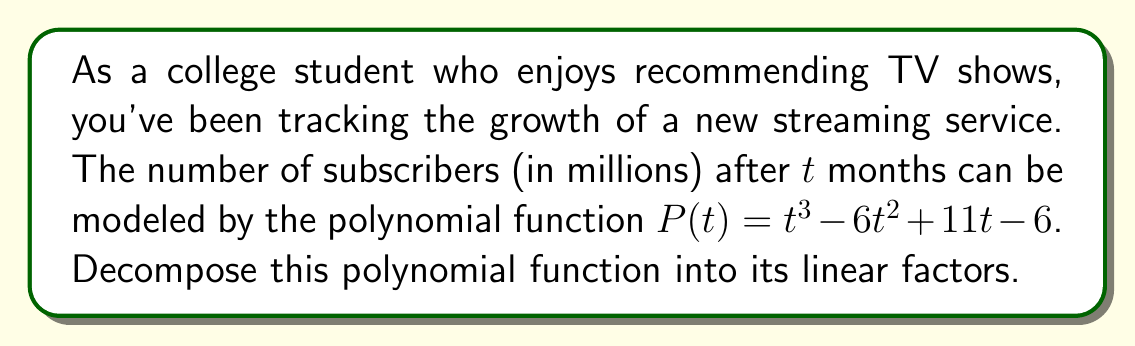Help me with this question. To decompose this polynomial function, we'll follow these steps:

1) First, let's check if there are any rational roots using the rational root theorem. The possible rational roots are the factors of the constant term: $\pm 1, \pm 2, \pm 3, \pm 6$.

2) Testing these values, we find that $P(1) = 0$. So $(t-1)$ is a factor.

3) We can use polynomial long division to divide $P(t)$ by $(t-1)$:

   $$\frac{t^3 - 6t^2 + 11t - 6}{t-1} = t^2 - 5t + 6$$

4) Now we have: $P(t) = (t-1)(t^2 - 5t + 6)$

5) The quadratic factor $t^2 - 5t + 6$ can be factored further:
   
   $$t^2 - 5t + 6 = (t-2)(t-3)$$

6) Combining all factors, we get:

   $$P(t) = (t-1)(t-2)(t-3)$$

Thus, we've decomposed the polynomial into its linear factors.
Answer: $P(t) = (t-1)(t-2)(t-3)$ 